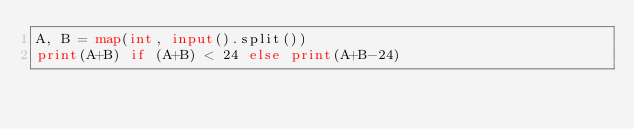Convert code to text. <code><loc_0><loc_0><loc_500><loc_500><_Python_>A, B = map(int, input().split())
print(A+B) if (A+B) < 24 else print(A+B-24)</code> 